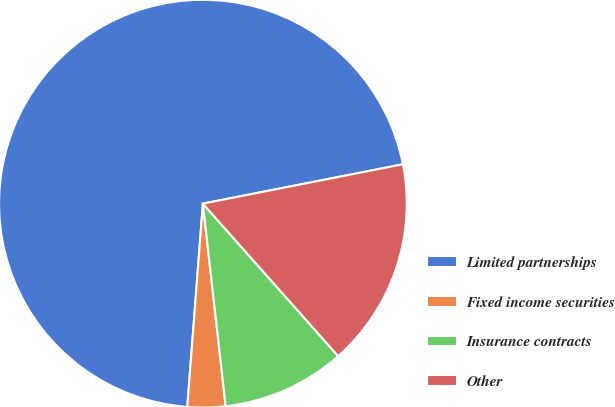Convert chart to OTSL. <chart><loc_0><loc_0><loc_500><loc_500><pie_chart><fcel>Limited partnerships<fcel>Fixed income securities<fcel>Insurance contracts<fcel>Other<nl><fcel>70.69%<fcel>3.0%<fcel>9.77%<fcel>16.54%<nl></chart> 